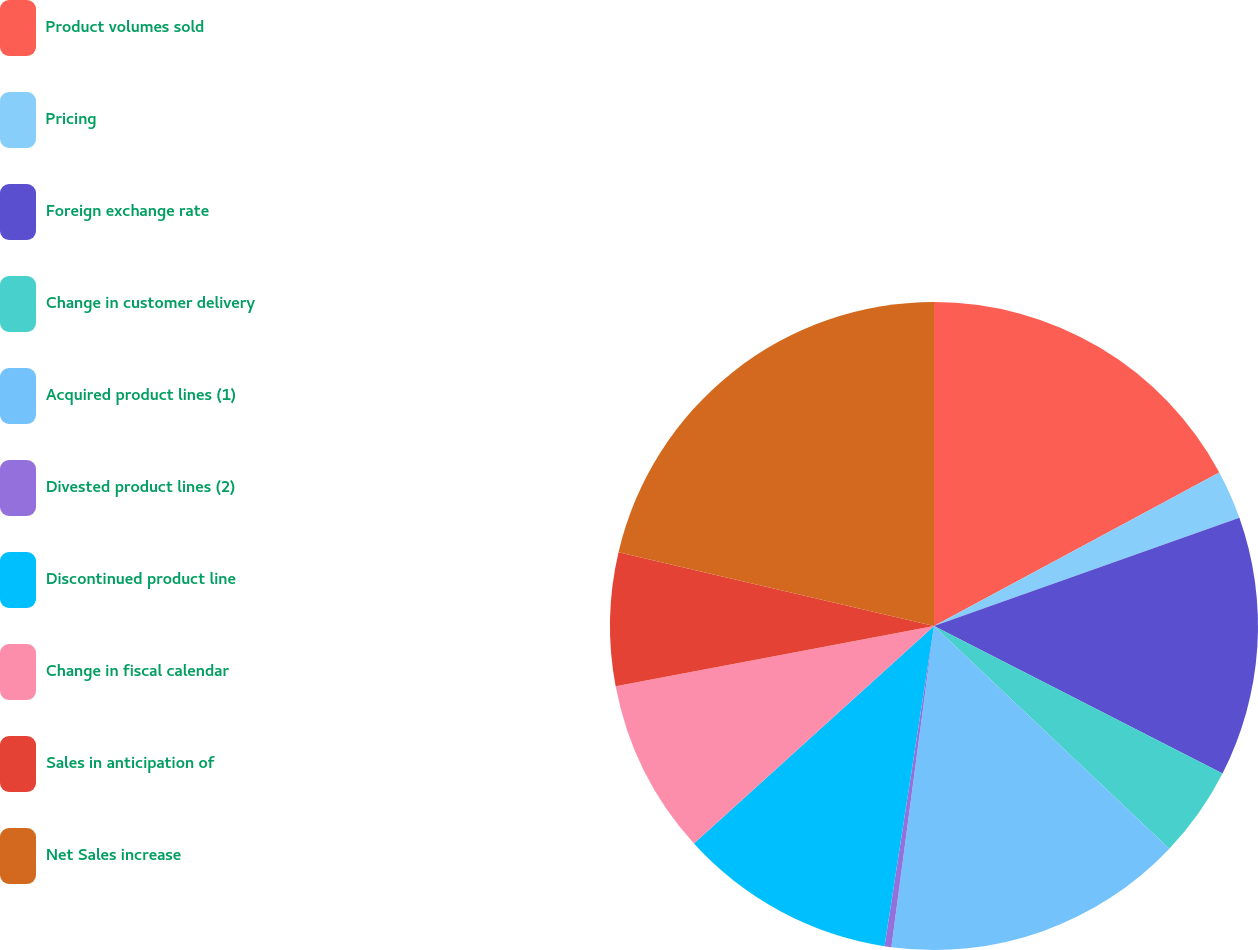<chart> <loc_0><loc_0><loc_500><loc_500><pie_chart><fcel>Product volumes sold<fcel>Pricing<fcel>Foreign exchange rate<fcel>Change in customer delivery<fcel>Acquired product lines (1)<fcel>Divested product lines (2)<fcel>Discontinued product line<fcel>Change in fiscal calendar<fcel>Sales in anticipation of<fcel>Net Sales increase<nl><fcel>17.14%<fcel>2.44%<fcel>12.94%<fcel>4.54%<fcel>15.04%<fcel>0.34%<fcel>10.84%<fcel>8.74%<fcel>6.64%<fcel>21.34%<nl></chart> 